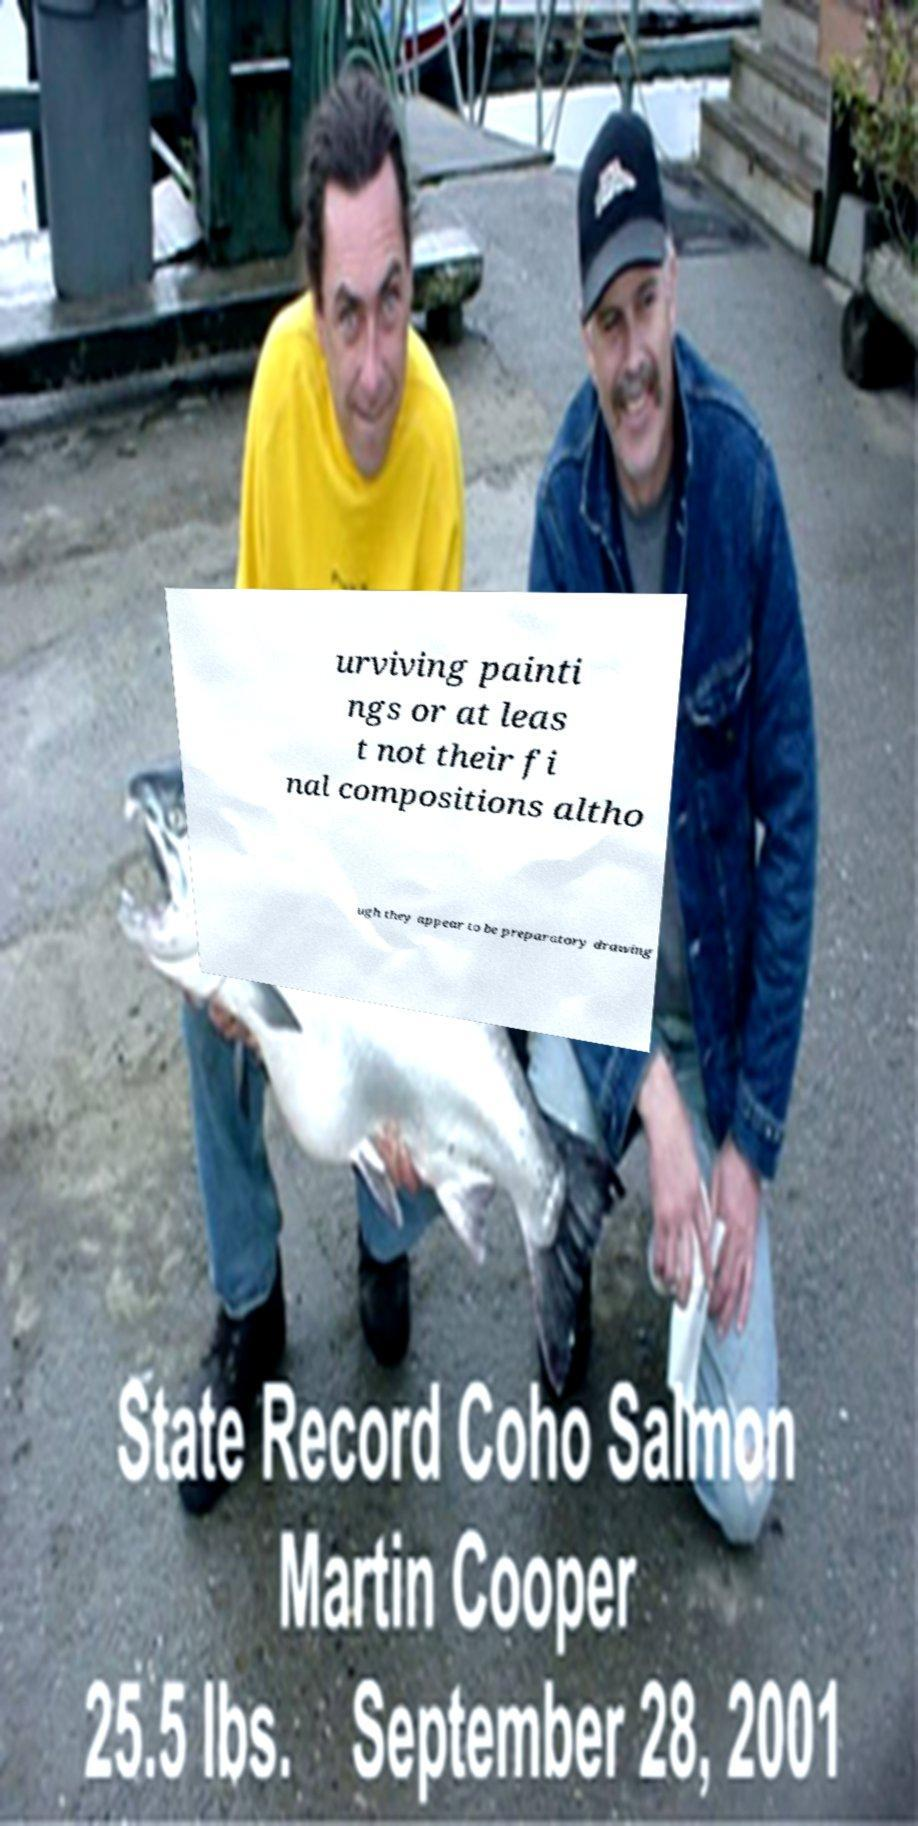Can you read and provide the text displayed in the image?This photo seems to have some interesting text. Can you extract and type it out for me? urviving painti ngs or at leas t not their fi nal compositions altho ugh they appear to be preparatory drawing 